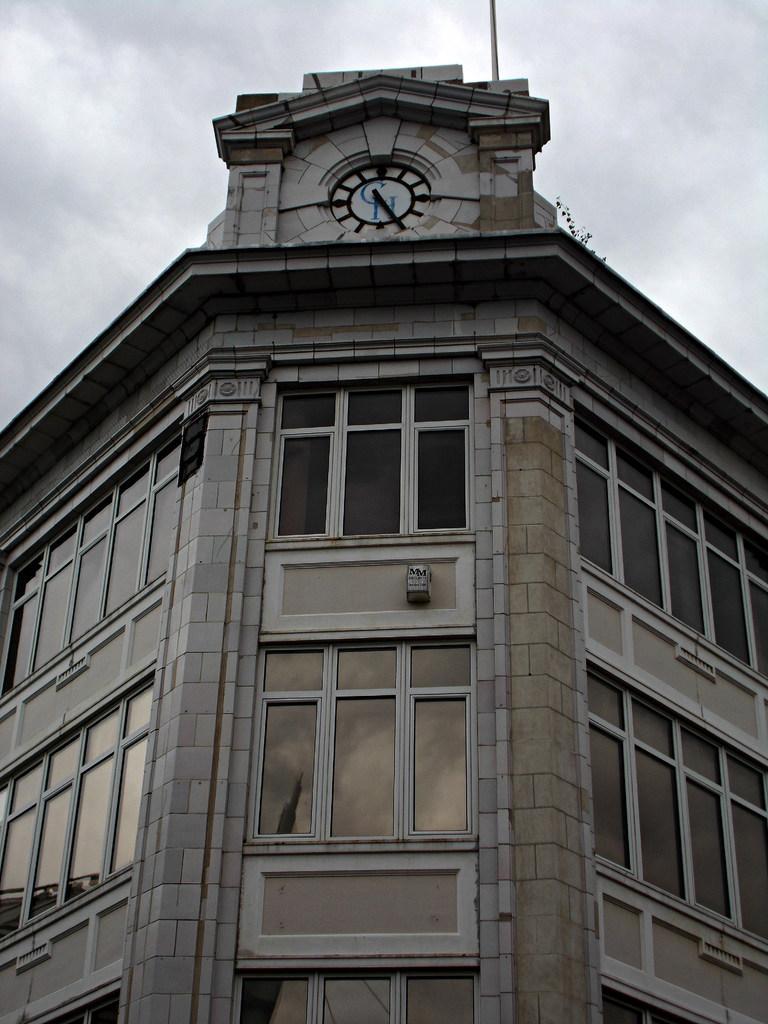Could you give a brief overview of what you see in this image? In this picture we can see a building with windows, clock, pole and in the background we can see the sky with clouds. 